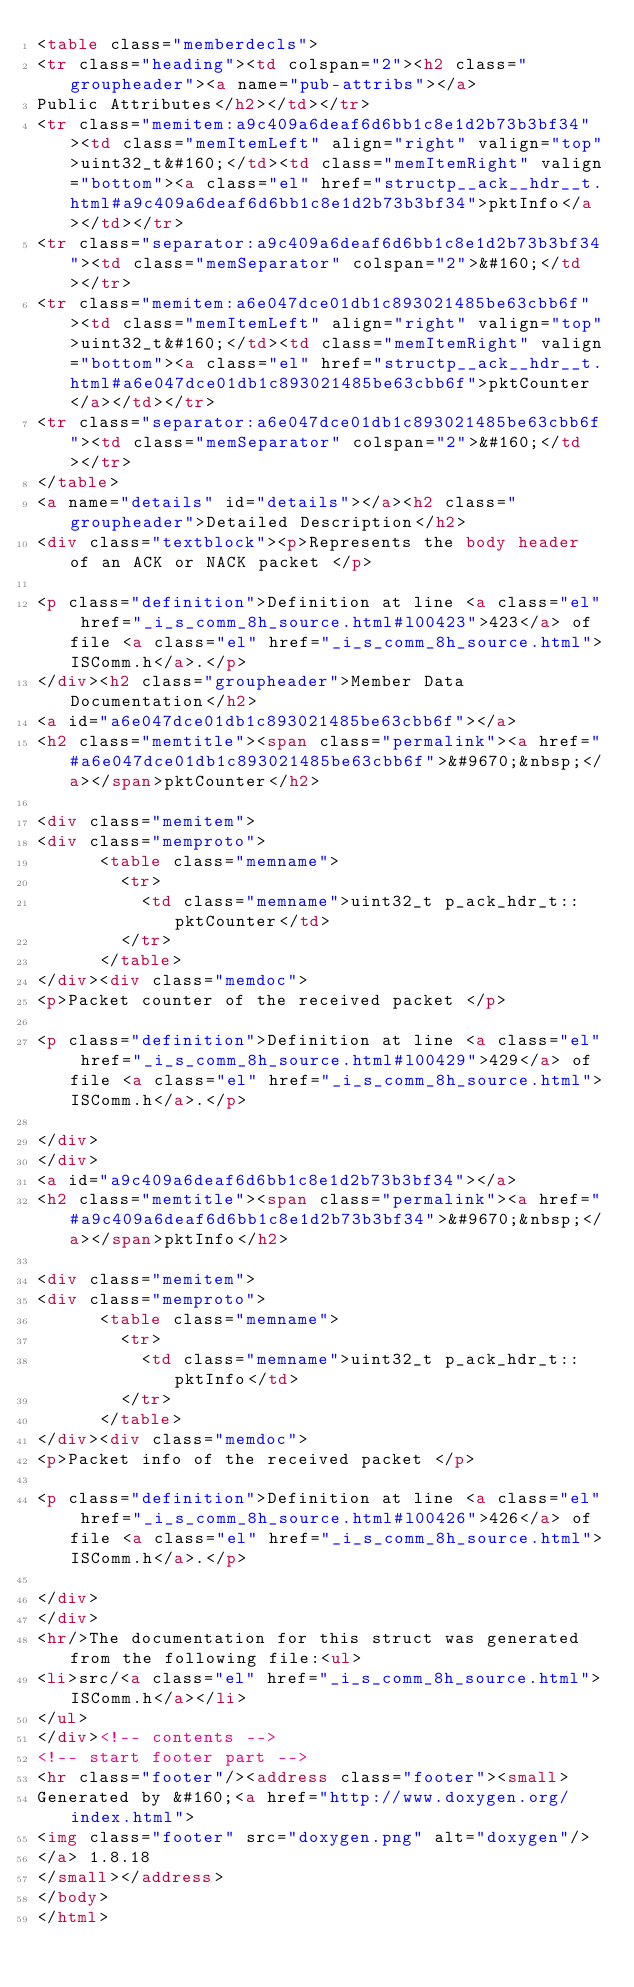Convert code to text. <code><loc_0><loc_0><loc_500><loc_500><_HTML_><table class="memberdecls">
<tr class="heading"><td colspan="2"><h2 class="groupheader"><a name="pub-attribs"></a>
Public Attributes</h2></td></tr>
<tr class="memitem:a9c409a6deaf6d6bb1c8e1d2b73b3bf34"><td class="memItemLeft" align="right" valign="top">uint32_t&#160;</td><td class="memItemRight" valign="bottom"><a class="el" href="structp__ack__hdr__t.html#a9c409a6deaf6d6bb1c8e1d2b73b3bf34">pktInfo</a></td></tr>
<tr class="separator:a9c409a6deaf6d6bb1c8e1d2b73b3bf34"><td class="memSeparator" colspan="2">&#160;</td></tr>
<tr class="memitem:a6e047dce01db1c893021485be63cbb6f"><td class="memItemLeft" align="right" valign="top">uint32_t&#160;</td><td class="memItemRight" valign="bottom"><a class="el" href="structp__ack__hdr__t.html#a6e047dce01db1c893021485be63cbb6f">pktCounter</a></td></tr>
<tr class="separator:a6e047dce01db1c893021485be63cbb6f"><td class="memSeparator" colspan="2">&#160;</td></tr>
</table>
<a name="details" id="details"></a><h2 class="groupheader">Detailed Description</h2>
<div class="textblock"><p>Represents the body header of an ACK or NACK packet </p>

<p class="definition">Definition at line <a class="el" href="_i_s_comm_8h_source.html#l00423">423</a> of file <a class="el" href="_i_s_comm_8h_source.html">ISComm.h</a>.</p>
</div><h2 class="groupheader">Member Data Documentation</h2>
<a id="a6e047dce01db1c893021485be63cbb6f"></a>
<h2 class="memtitle"><span class="permalink"><a href="#a6e047dce01db1c893021485be63cbb6f">&#9670;&nbsp;</a></span>pktCounter</h2>

<div class="memitem">
<div class="memproto">
      <table class="memname">
        <tr>
          <td class="memname">uint32_t p_ack_hdr_t::pktCounter</td>
        </tr>
      </table>
</div><div class="memdoc">
<p>Packet counter of the received packet </p>

<p class="definition">Definition at line <a class="el" href="_i_s_comm_8h_source.html#l00429">429</a> of file <a class="el" href="_i_s_comm_8h_source.html">ISComm.h</a>.</p>

</div>
</div>
<a id="a9c409a6deaf6d6bb1c8e1d2b73b3bf34"></a>
<h2 class="memtitle"><span class="permalink"><a href="#a9c409a6deaf6d6bb1c8e1d2b73b3bf34">&#9670;&nbsp;</a></span>pktInfo</h2>

<div class="memitem">
<div class="memproto">
      <table class="memname">
        <tr>
          <td class="memname">uint32_t p_ack_hdr_t::pktInfo</td>
        </tr>
      </table>
</div><div class="memdoc">
<p>Packet info of the received packet </p>

<p class="definition">Definition at line <a class="el" href="_i_s_comm_8h_source.html#l00426">426</a> of file <a class="el" href="_i_s_comm_8h_source.html">ISComm.h</a>.</p>

</div>
</div>
<hr/>The documentation for this struct was generated from the following file:<ul>
<li>src/<a class="el" href="_i_s_comm_8h_source.html">ISComm.h</a></li>
</ul>
</div><!-- contents -->
<!-- start footer part -->
<hr class="footer"/><address class="footer"><small>
Generated by &#160;<a href="http://www.doxygen.org/index.html">
<img class="footer" src="doxygen.png" alt="doxygen"/>
</a> 1.8.18
</small></address>
</body>
</html>
</code> 